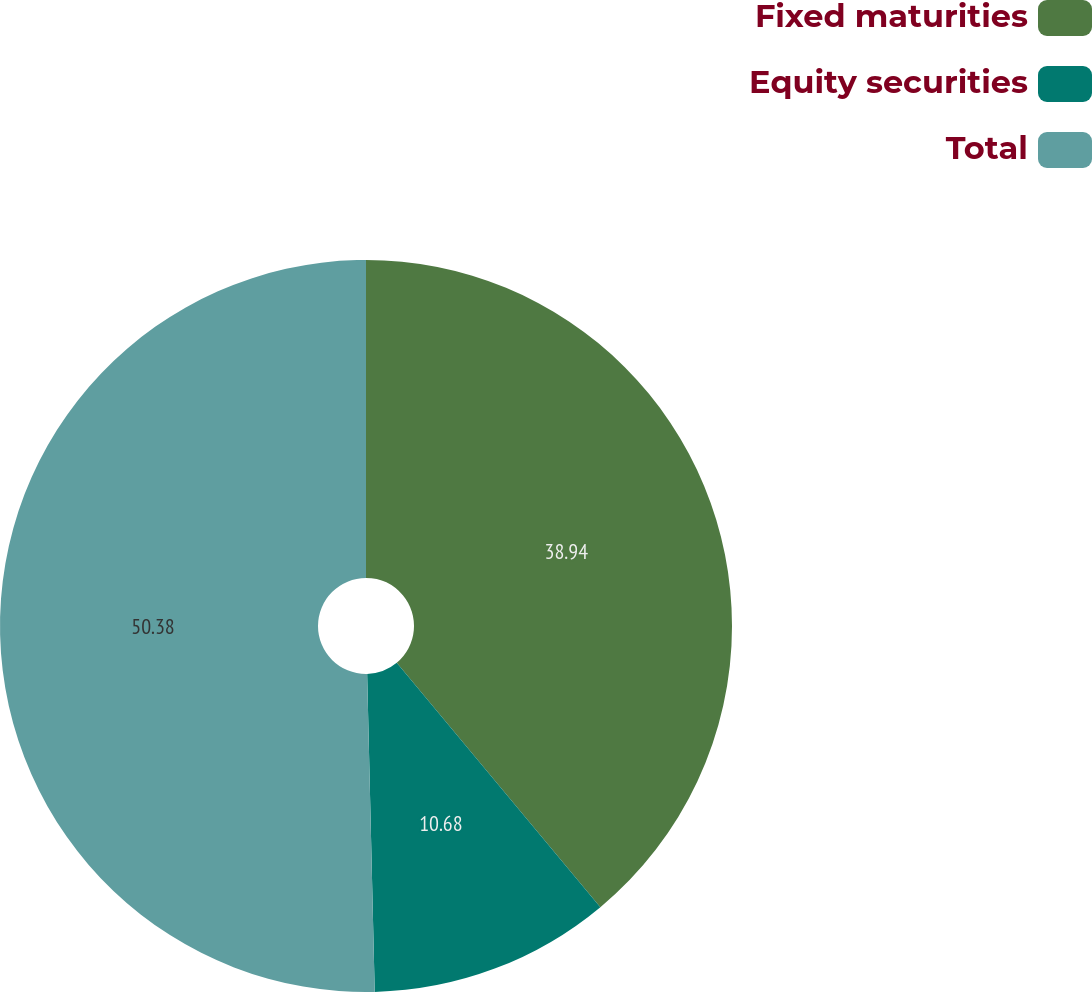<chart> <loc_0><loc_0><loc_500><loc_500><pie_chart><fcel>Fixed maturities<fcel>Equity securities<fcel>Total<nl><fcel>38.94%<fcel>10.68%<fcel>50.38%<nl></chart> 